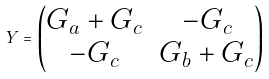Convert formula to latex. <formula><loc_0><loc_0><loc_500><loc_500>Y = \left ( \begin{matrix} G _ { a } + G _ { c } & - G _ { c } \\ - G _ { c } & G _ { b } + G _ { c } \end{matrix} \right )</formula> 